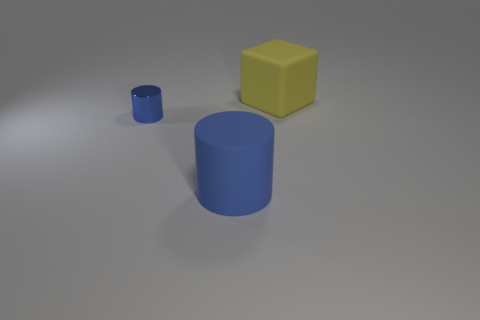Is there any other thing that is the same material as the tiny blue cylinder?
Ensure brevity in your answer.  No. What shape is the blue object that is the same size as the yellow rubber block?
Offer a very short reply. Cylinder. There is a cylinder left of the big object that is on the left side of the large matte thing behind the blue matte cylinder; what is its size?
Your answer should be very brief. Small. Does the big cylinder have the same color as the tiny cylinder?
Your answer should be compact. Yes. Is there anything else that has the same size as the yellow rubber object?
Provide a short and direct response. Yes. There is a matte block; what number of rubber cylinders are behind it?
Your answer should be compact. 0. Is the number of blue metal cylinders that are to the right of the yellow object the same as the number of big purple matte cylinders?
Offer a very short reply. Yes. How many objects are either brown rubber cubes or blue cylinders?
Provide a short and direct response. 2. Is there any other thing that is the same shape as the big yellow matte object?
Your response must be concise. No. What is the shape of the large matte object on the right side of the object in front of the small shiny thing?
Give a very brief answer. Cube. 